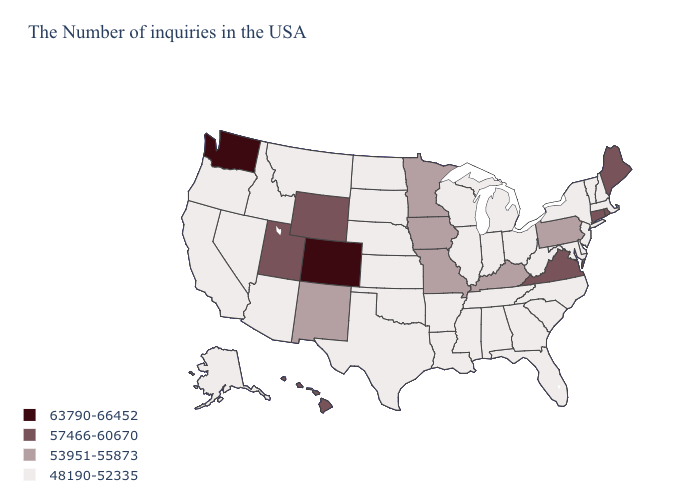What is the value of Alabama?
Answer briefly. 48190-52335. Name the states that have a value in the range 48190-52335?
Answer briefly. Massachusetts, New Hampshire, Vermont, New York, New Jersey, Delaware, Maryland, North Carolina, South Carolina, West Virginia, Ohio, Florida, Georgia, Michigan, Indiana, Alabama, Tennessee, Wisconsin, Illinois, Mississippi, Louisiana, Arkansas, Kansas, Nebraska, Oklahoma, Texas, South Dakota, North Dakota, Montana, Arizona, Idaho, Nevada, California, Oregon, Alaska. What is the highest value in states that border New York?
Give a very brief answer. 57466-60670. Which states have the lowest value in the West?
Short answer required. Montana, Arizona, Idaho, Nevada, California, Oregon, Alaska. Is the legend a continuous bar?
Write a very short answer. No. Does Iowa have the highest value in the MidWest?
Answer briefly. Yes. Name the states that have a value in the range 63790-66452?
Short answer required. Colorado, Washington. What is the value of Maine?
Write a very short answer. 57466-60670. Among the states that border South Dakota , does Wyoming have the highest value?
Be succinct. Yes. What is the value of Alabama?
Write a very short answer. 48190-52335. What is the lowest value in states that border Nebraska?
Keep it brief. 48190-52335. Which states have the lowest value in the USA?
Give a very brief answer. Massachusetts, New Hampshire, Vermont, New York, New Jersey, Delaware, Maryland, North Carolina, South Carolina, West Virginia, Ohio, Florida, Georgia, Michigan, Indiana, Alabama, Tennessee, Wisconsin, Illinois, Mississippi, Louisiana, Arkansas, Kansas, Nebraska, Oklahoma, Texas, South Dakota, North Dakota, Montana, Arizona, Idaho, Nevada, California, Oregon, Alaska. Name the states that have a value in the range 53951-55873?
Concise answer only. Pennsylvania, Kentucky, Missouri, Minnesota, Iowa, New Mexico. What is the value of Florida?
Keep it brief. 48190-52335. 